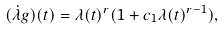<formula> <loc_0><loc_0><loc_500><loc_500>( \dot { \lambda } g ) ( t ) = \lambda ( t ) ^ { r } ( 1 + c _ { 1 } \lambda ( t ) ^ { r - 1 } ) ,</formula> 